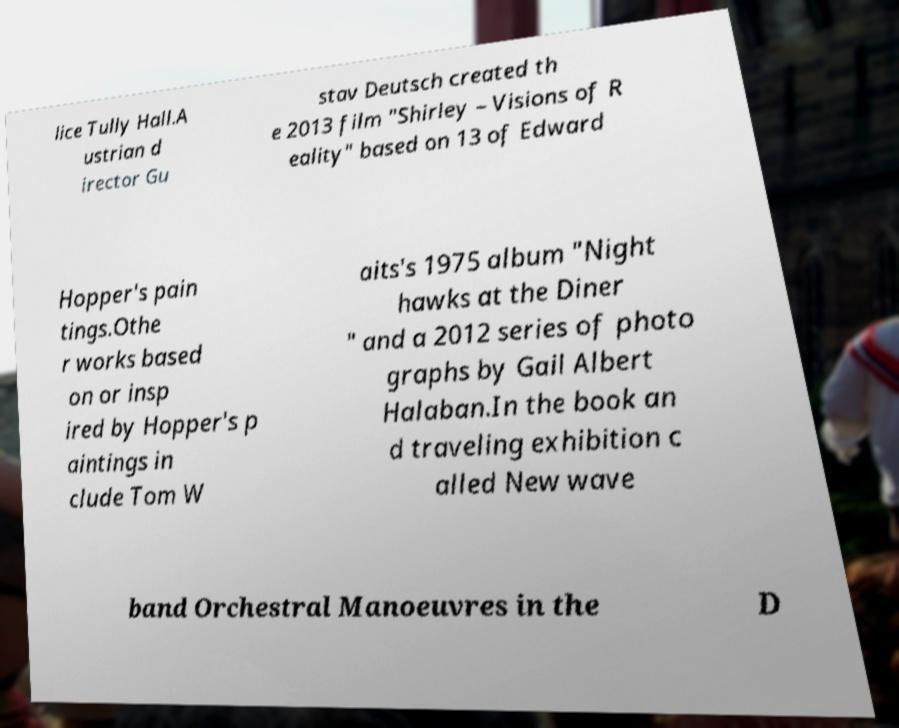For documentation purposes, I need the text within this image transcribed. Could you provide that? lice Tully Hall.A ustrian d irector Gu stav Deutsch created th e 2013 film "Shirley – Visions of R eality" based on 13 of Edward Hopper's pain tings.Othe r works based on or insp ired by Hopper's p aintings in clude Tom W aits's 1975 album "Night hawks at the Diner " and a 2012 series of photo graphs by Gail Albert Halaban.In the book an d traveling exhibition c alled New wave band Orchestral Manoeuvres in the D 